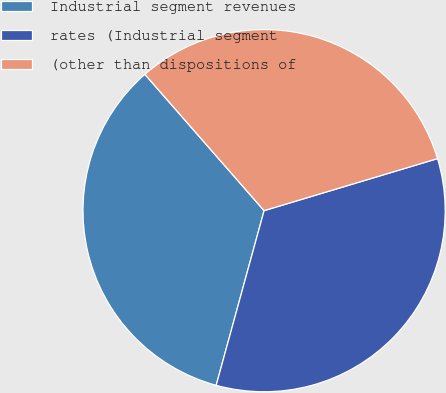Convert chart. <chart><loc_0><loc_0><loc_500><loc_500><pie_chart><fcel>Industrial segment revenues<fcel>rates (Industrial segment<fcel>(other than dispositions of<nl><fcel>34.3%<fcel>33.9%<fcel>31.79%<nl></chart> 